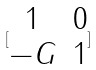<formula> <loc_0><loc_0><loc_500><loc_500>[ \begin{matrix} 1 & 0 \\ - G & 1 \end{matrix} ]</formula> 